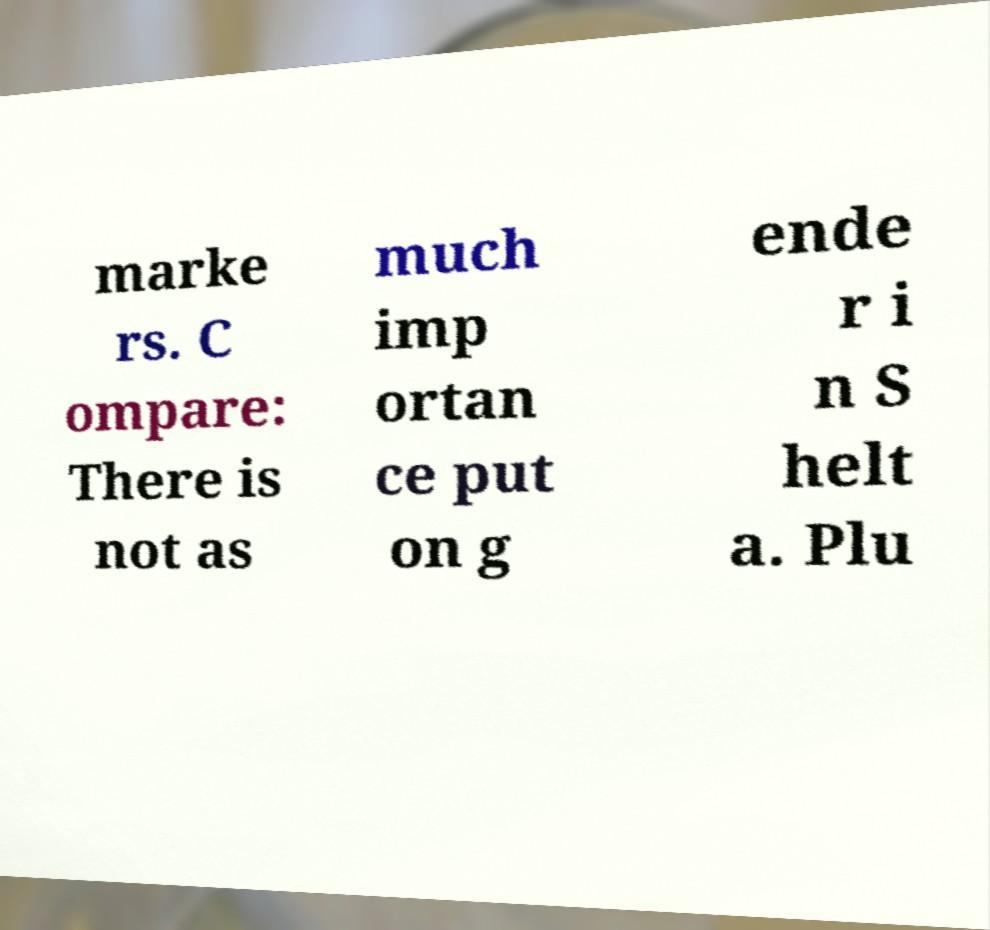Could you assist in decoding the text presented in this image and type it out clearly? marke rs. C ompare: There is not as much imp ortan ce put on g ende r i n S helt a. Plu 